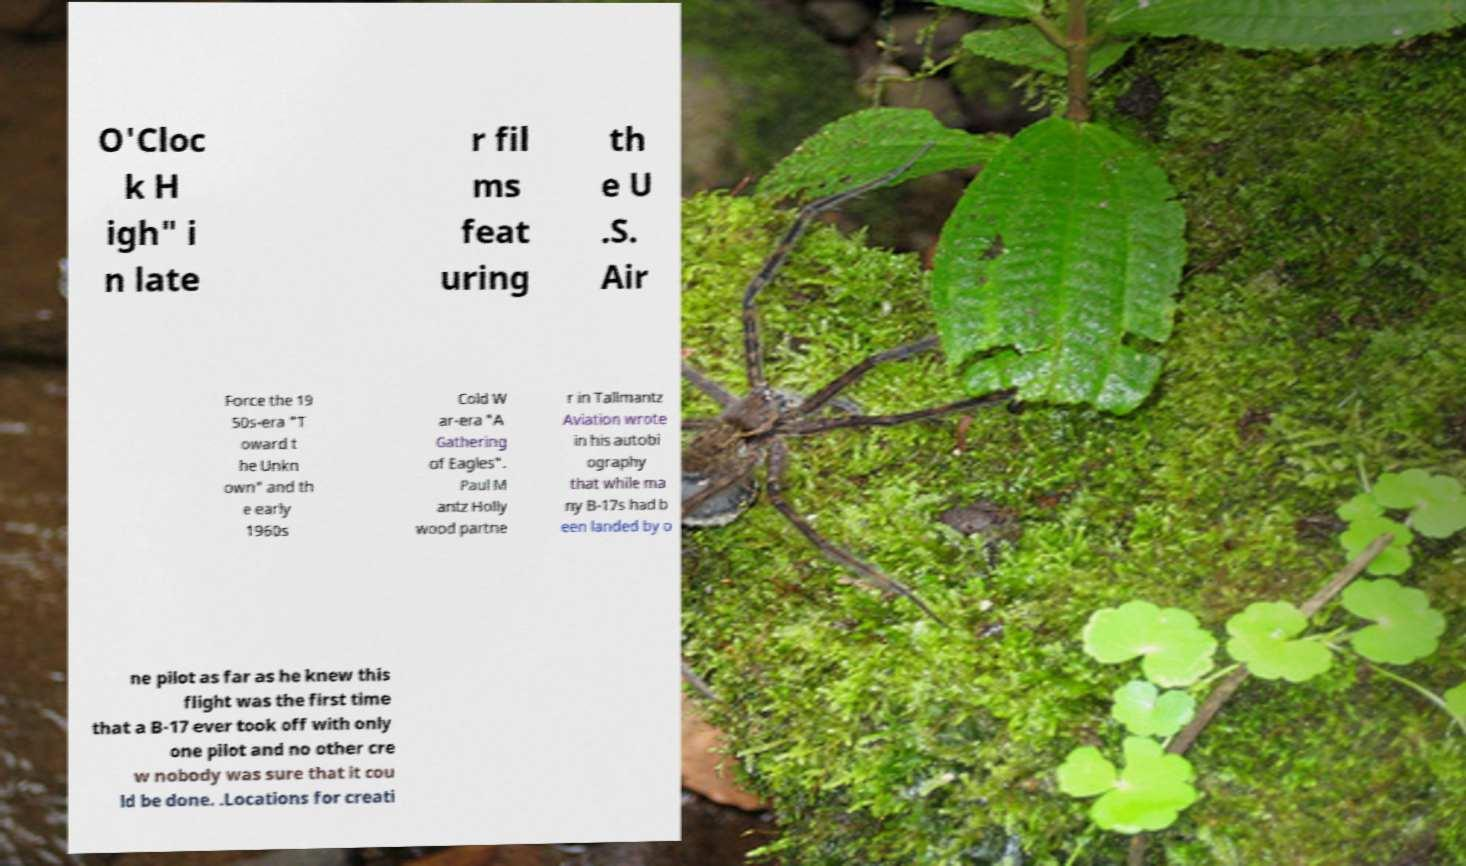Can you accurately transcribe the text from the provided image for me? O'Cloc k H igh" i n late r fil ms feat uring th e U .S. Air Force the 19 50s-era "T oward t he Unkn own" and th e early 1960s Cold W ar-era "A Gathering of Eagles". Paul M antz Holly wood partne r in Tallmantz Aviation wrote in his autobi ography that while ma ny B-17s had b een landed by o ne pilot as far as he knew this flight was the first time that a B-17 ever took off with only one pilot and no other cre w nobody was sure that it cou ld be done. .Locations for creati 